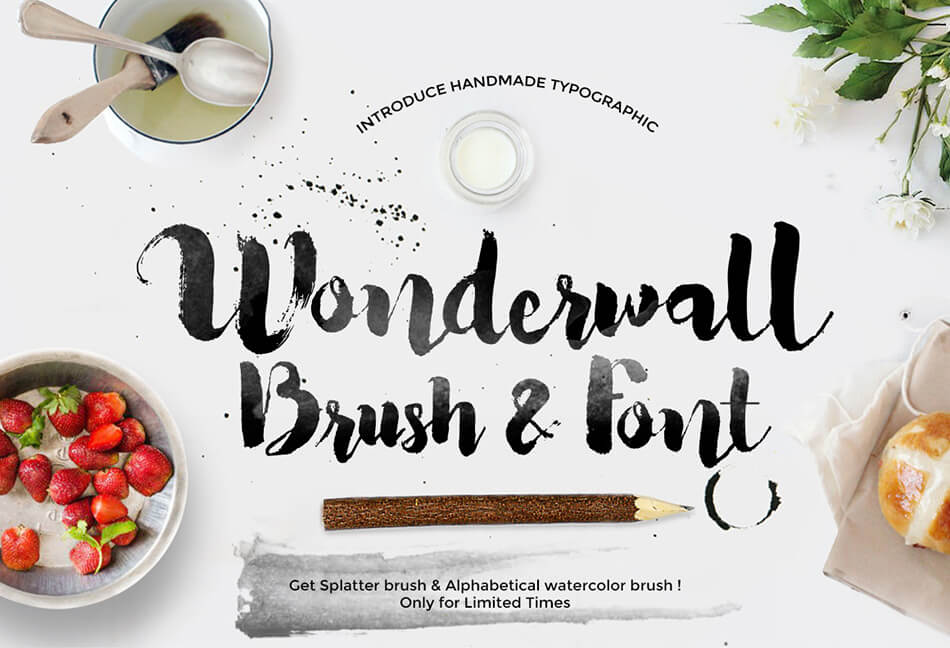Considering the elements presented in the advertisement, what might be the intended use or application for the 'Wonderwall' brush and font style, and how do these elements collectively enhance the appeal or functionality of the product being advertised? The 'Wonderwall' brush and font style is predominantly designed for creative endeavors in graphic design, especially suitable for projects that seek an artistic, handcrafted aesthetic. The visual of the advertisement itself highlights a range of materials including paintbrushes, pencils, and a display of strawberries and bread, all strategically used to underscore the versatility of the font for various industries, particularly the food sector. The messy, yet appealing splatter effects and the fresh strawberries suggest an ability to appeal to gourmet and organic markets, indicating that this font could be ideal for marketing organic products or artisan foods. Furthermore, the presence of a wooden pencil and natural flowers elevates the organic and eco-friendly appeal, aligning with brands that value sustainability. The advertisement itself serves as a showcase of the font's capability to blend seamlessly into different themes, from natural and rustic to modern and artistic, making it a valuable tool for designers wanting to convey distinct, effective messages through their visuals. 